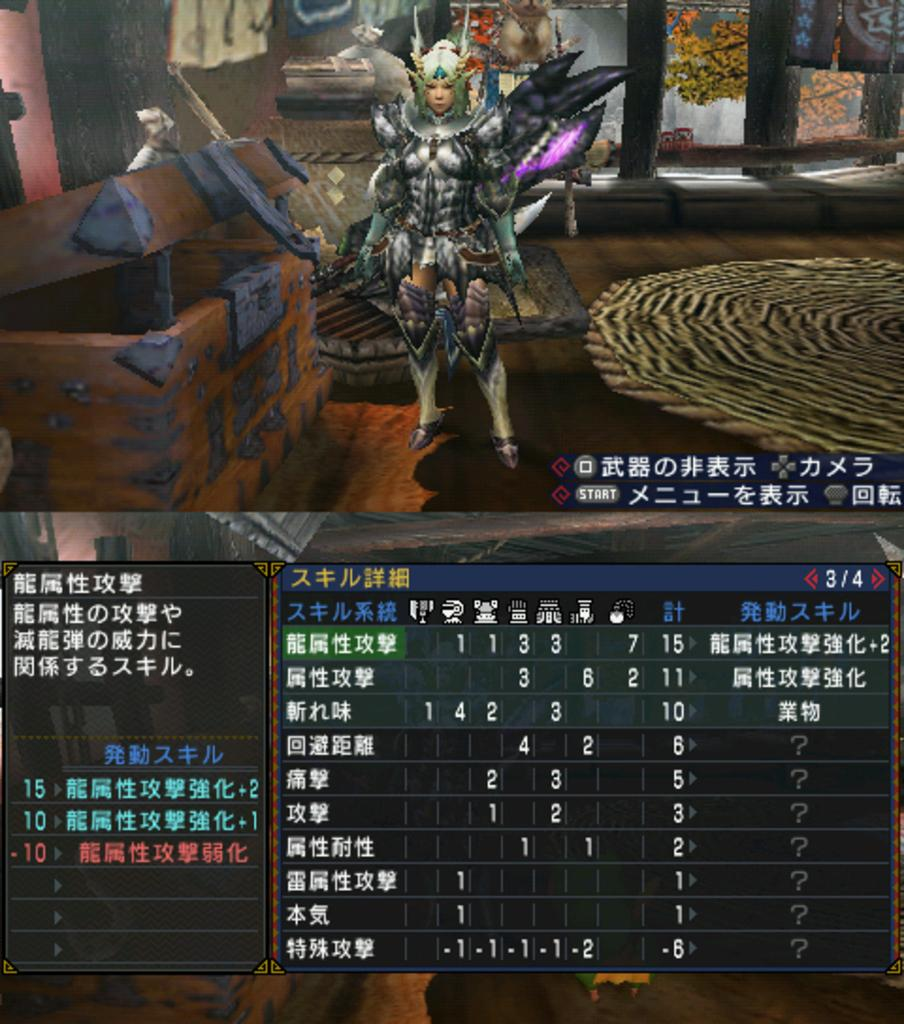<image>
Present a compact description of the photo's key features. some Japanese writing that is on a screen 